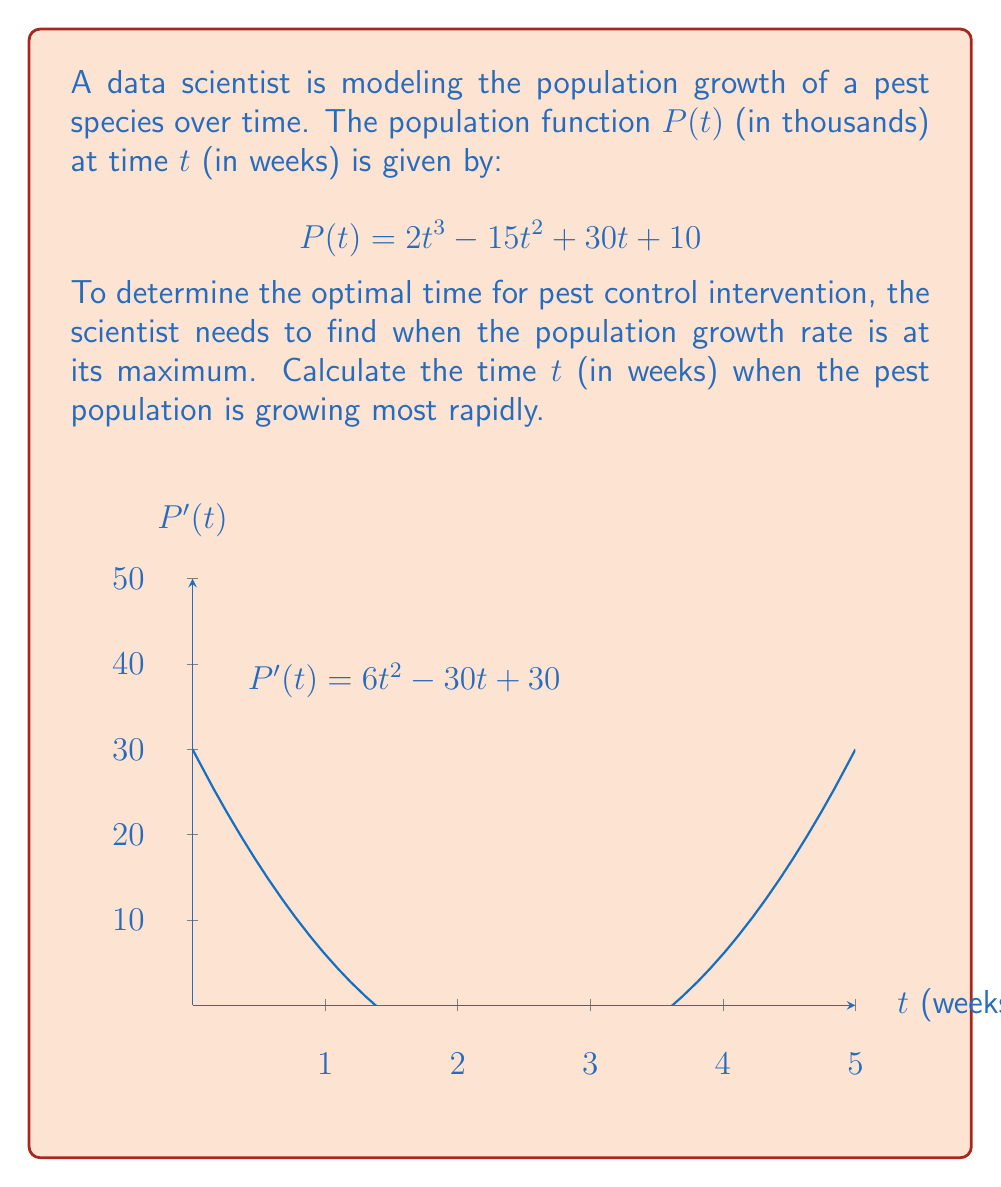Can you answer this question? To find when the population is growing most rapidly, we need to:
1. Find the derivative of $P(t)$ to get the growth rate function.
2. Find the critical points of the growth rate function.
3. Determine which critical point gives the maximum growth rate.

Step 1: Find $P'(t)$
$$P'(t) = 6t^2 - 30t + 30$$

Step 2: Find critical points
Set $P'(t) = 0$ and solve:
$$6t^2 - 30t + 30 = 0$$
$$6(t^2 - 5t + 5) = 0$$
$$t^2 - 5t + 5 = 0$$

Using the quadratic formula: $t = \frac{5 \pm \sqrt{25 - 20}}{2} = \frac{5 \pm \sqrt{5}}{2}$

Critical points: $t_1 = \frac{5 + \sqrt{5}}{2}$ and $t_2 = \frac{5 - \sqrt{5}}{2}$

Step 3: Determine maximum growth rate
To find which critical point gives the maximum growth rate, we need to find $P''(t)$:

$$P''(t) = 12t - 30$$

Evaluate $P''(t)$ at each critical point:

At $t_1 = \frac{5 + \sqrt{5}}{2}$:
$$P''(t_1) = 12(\frac{5 + \sqrt{5}}{2}) - 30 = 30 + 6\sqrt{5} - 30 = 6\sqrt{5} > 0$$

At $t_2 = \frac{5 - \sqrt{5}}{2}$:
$$P''(t_2) = 12(\frac{5 - \sqrt{5}}{2}) - 30 = 30 - 6\sqrt{5} - 30 = -6\sqrt{5} < 0$$

Since $P''(t_1) > 0$ and $P''(t_2) < 0$, the maximum growth rate occurs at $t_2 = \frac{5 - \sqrt{5}}{2}$.
Answer: $\frac{5 - \sqrt{5}}{2}$ weeks 